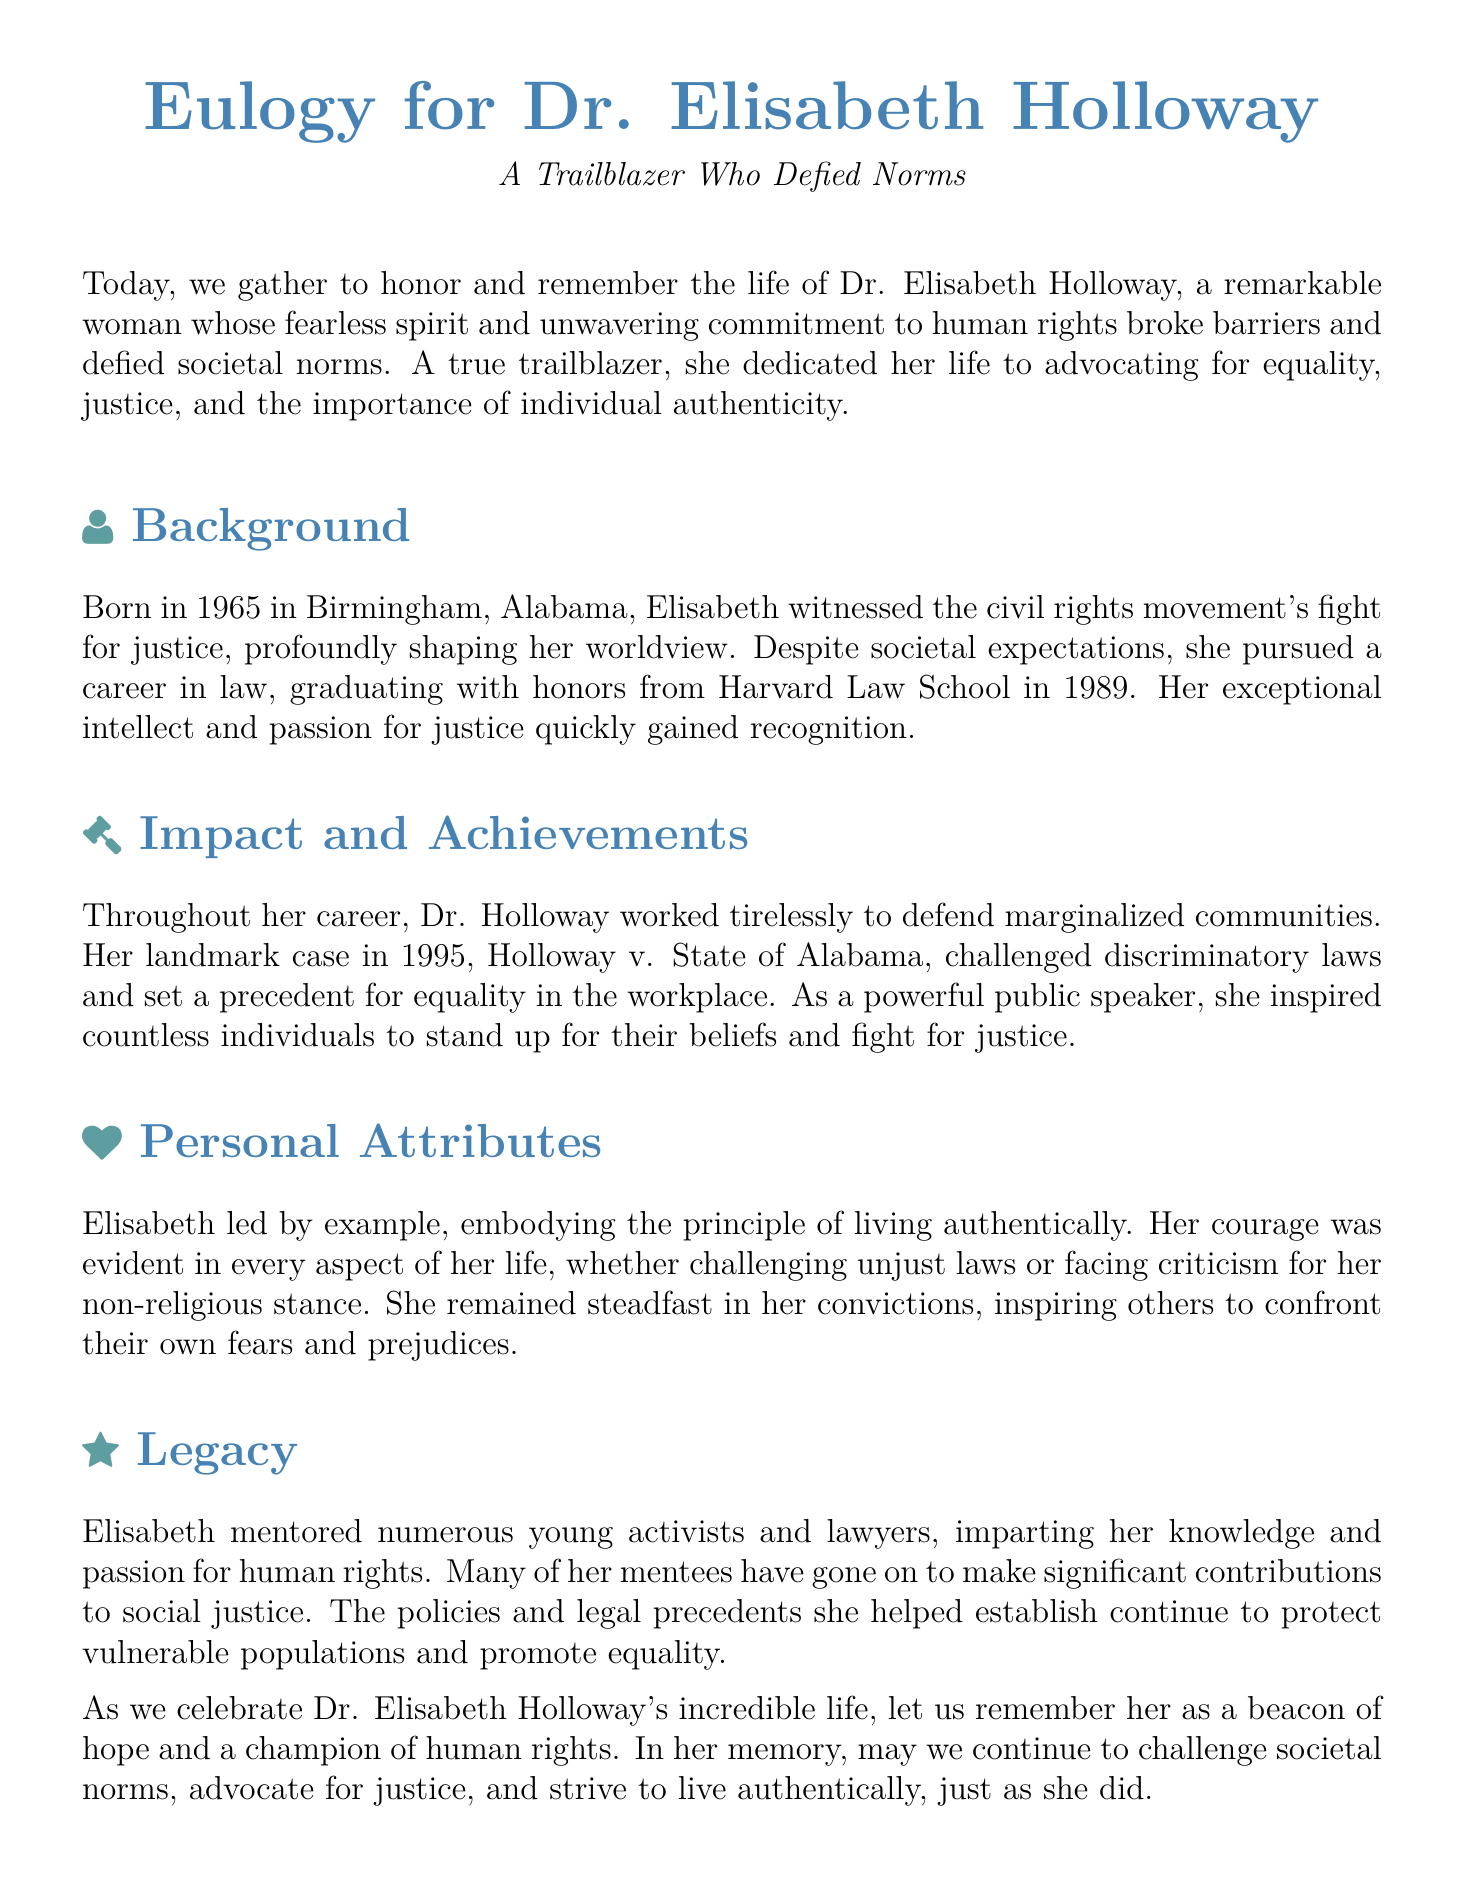What year was Dr. Elisabeth Holloway born? The document states her birth year as 1965.
Answer: 1965 What is the title of the landmark case Elisabeth was involved in? The document mentions the case as Holloway v. State of Alabama.
Answer: Holloway v. State of Alabama What degree did Dr. Holloway earn at Harvard Law School? She graduated with honors, which implies a law degree.
Answer: Law In which city was Dr. Elisabeth Holloway born? The document indicates that she was born in Birmingham, Alabama.
Answer: Birmingham, Alabama What did Elisabeth Holloway advocate for throughout her career? She dedicated her life to advocating for equality and justice.
Answer: Equality and justice How did Dr. Holloway inspire others according to the document? By being a powerful public speaker.
Answer: Powerful public speaker What personal stance of Dr. Holloway is highlighted in the eulogy? Her non-religious stance is explicitly mentioned.
Answer: Non-religious stance What year did Dr. Holloway graduate from Harvard? The document notes she graduated in 1989.
Answer: 1989 What kind of legacy did Dr. Holloway leave behind? She mentored numerous young activists and lawyers.
Answer: Mentored young activists and lawyers 